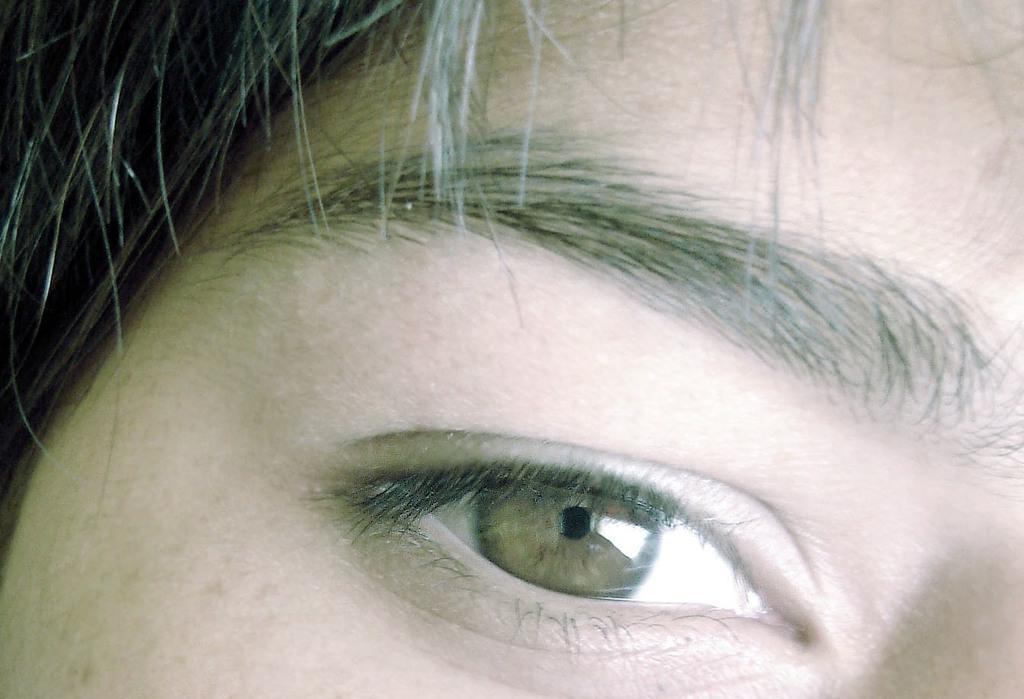Describe this image in one or two sentences. In this image we can see an eye and eyebrow of a person. 